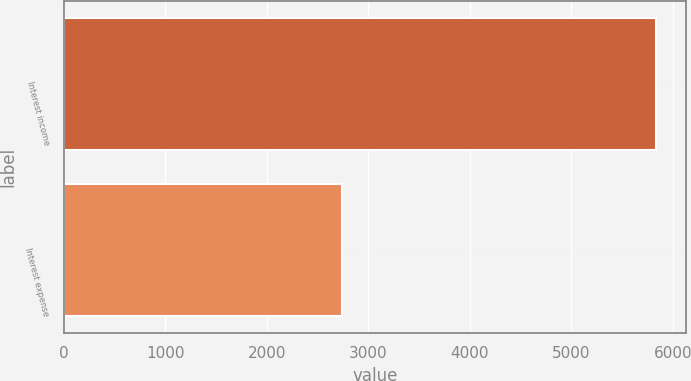Convert chart. <chart><loc_0><loc_0><loc_500><loc_500><bar_chart><fcel>Interest income<fcel>Interest expense<nl><fcel>5835<fcel>2742<nl></chart> 